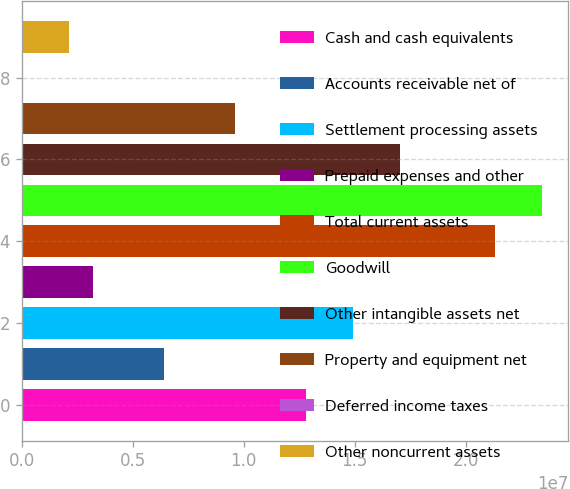Convert chart. <chart><loc_0><loc_0><loc_500><loc_500><bar_chart><fcel>Cash and cash equivalents<fcel>Accounts receivable net of<fcel>Settlement processing assets<fcel>Prepaid expenses and other<fcel>Total current assets<fcel>Goodwill<fcel>Other intangible assets net<fcel>Property and equipment net<fcel>Deferred income taxes<fcel>Other noncurrent assets<nl><fcel>1.27941e+07<fcel>6.40493e+06<fcel>1.49238e+07<fcel>3.21036e+06<fcel>2.13129e+07<fcel>2.34426e+07<fcel>1.70535e+07<fcel>9.59949e+06<fcel>15789<fcel>2.1455e+06<nl></chart> 